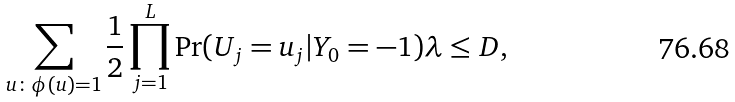<formula> <loc_0><loc_0><loc_500><loc_500>\sum _ { u \colon \phi ( u ) = 1 } \frac { 1 } { 2 } \prod _ { j = 1 } ^ { L } \Pr ( U _ { j } = u _ { j } | Y _ { 0 } = - 1 ) \lambda \leq D ,</formula> 